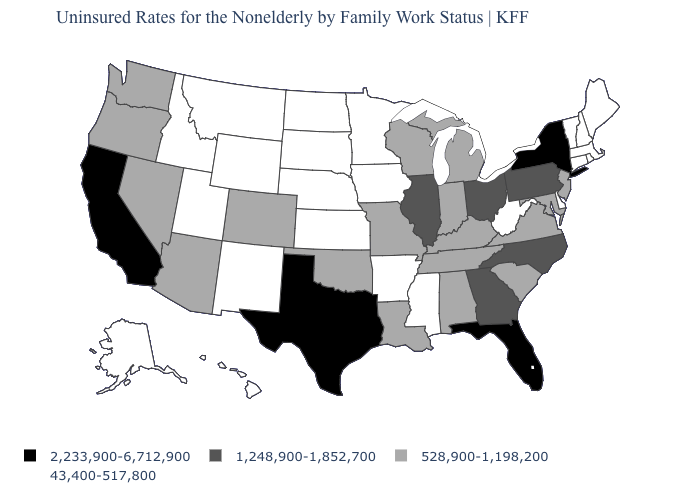Name the states that have a value in the range 1,248,900-1,852,700?
Keep it brief. Georgia, Illinois, North Carolina, Ohio, Pennsylvania. Name the states that have a value in the range 43,400-517,800?
Answer briefly. Alaska, Arkansas, Connecticut, Delaware, Hawaii, Idaho, Iowa, Kansas, Maine, Massachusetts, Minnesota, Mississippi, Montana, Nebraska, New Hampshire, New Mexico, North Dakota, Rhode Island, South Dakota, Utah, Vermont, West Virginia, Wyoming. How many symbols are there in the legend?
Quick response, please. 4. Name the states that have a value in the range 528,900-1,198,200?
Quick response, please. Alabama, Arizona, Colorado, Indiana, Kentucky, Louisiana, Maryland, Michigan, Missouri, Nevada, New Jersey, Oklahoma, Oregon, South Carolina, Tennessee, Virginia, Washington, Wisconsin. Name the states that have a value in the range 2,233,900-6,712,900?
Answer briefly. California, Florida, New York, Texas. Name the states that have a value in the range 2,233,900-6,712,900?
Answer briefly. California, Florida, New York, Texas. What is the lowest value in the South?
Quick response, please. 43,400-517,800. What is the value of Colorado?
Short answer required. 528,900-1,198,200. What is the value of Delaware?
Keep it brief. 43,400-517,800. What is the value of Florida?
Answer briefly. 2,233,900-6,712,900. What is the value of Connecticut?
Quick response, please. 43,400-517,800. Does Oregon have the lowest value in the West?
Quick response, please. No. Which states have the lowest value in the MidWest?
Quick response, please. Iowa, Kansas, Minnesota, Nebraska, North Dakota, South Dakota. What is the value of West Virginia?
Keep it brief. 43,400-517,800. What is the value of Oregon?
Quick response, please. 528,900-1,198,200. 